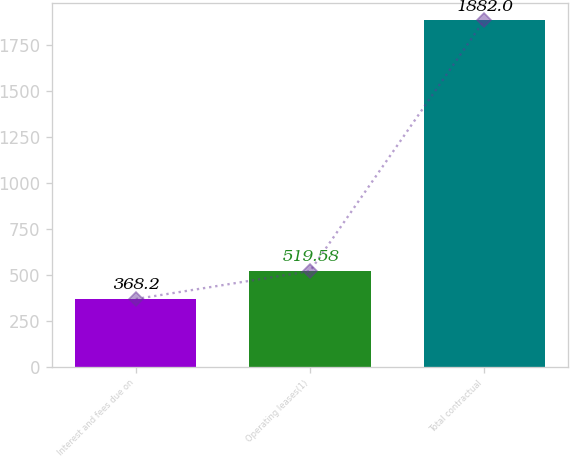Convert chart. <chart><loc_0><loc_0><loc_500><loc_500><bar_chart><fcel>Interest and fees due on<fcel>Operating leases(1)<fcel>Total contractual<nl><fcel>368.2<fcel>519.58<fcel>1882<nl></chart> 